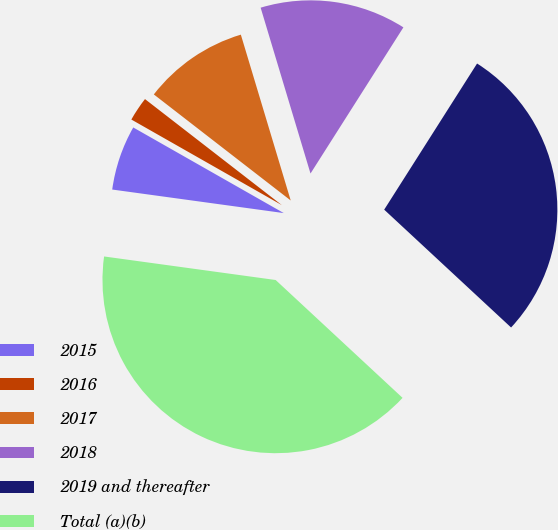Convert chart. <chart><loc_0><loc_0><loc_500><loc_500><pie_chart><fcel>2015<fcel>2016<fcel>2017<fcel>2018<fcel>2019 and thereafter<fcel>Total (a)(b)<nl><fcel>6.06%<fcel>2.26%<fcel>9.86%<fcel>13.66%<fcel>27.9%<fcel>40.26%<nl></chart> 